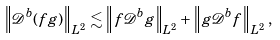Convert formula to latex. <formula><loc_0><loc_0><loc_500><loc_500>\left \| \mathcal { D } ^ { b } ( f g ) \right \| _ { L ^ { 2 } } \lesssim \left \| f \mathcal { D } ^ { b } g \right \| _ { L ^ { 2 } } + \left \| g \mathcal { D } ^ { b } f \right \| _ { L ^ { 2 } } ,</formula> 